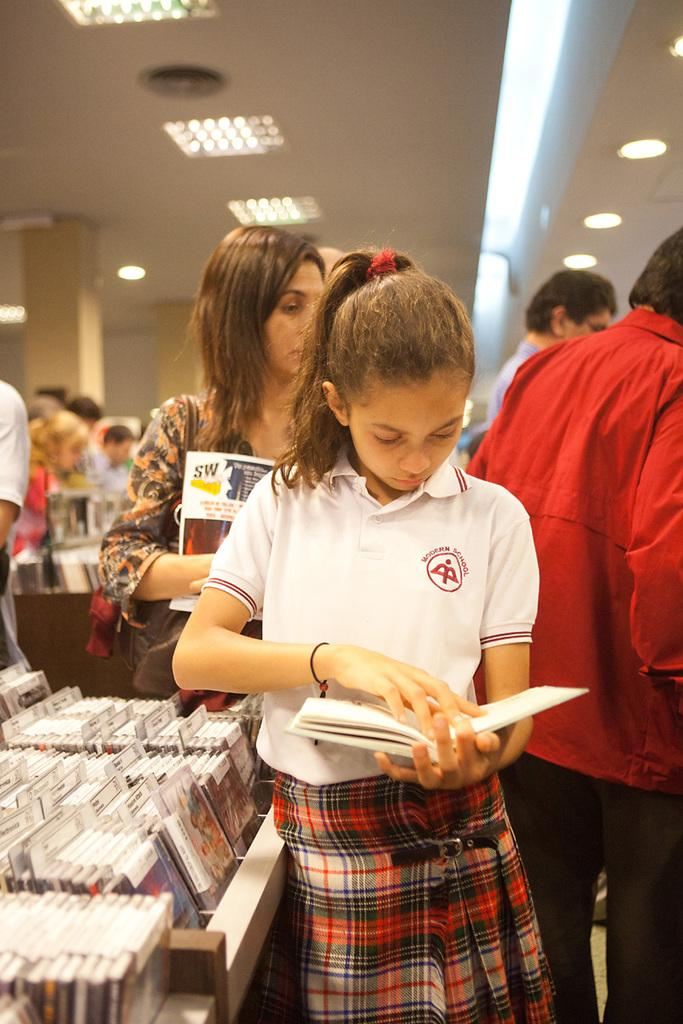What is the main subject in the foreground of the image? There is a girl in the foreground of the image. What is the girl holding in the image? The girl is holding a book. What is the girl wearing in the image? The girl is wearing a white T-shirt. What type of nose can be seen on the girl's daughter in the image? There is no mention of a daughter in the image, and therefore no nose can be observed on a daughter. 